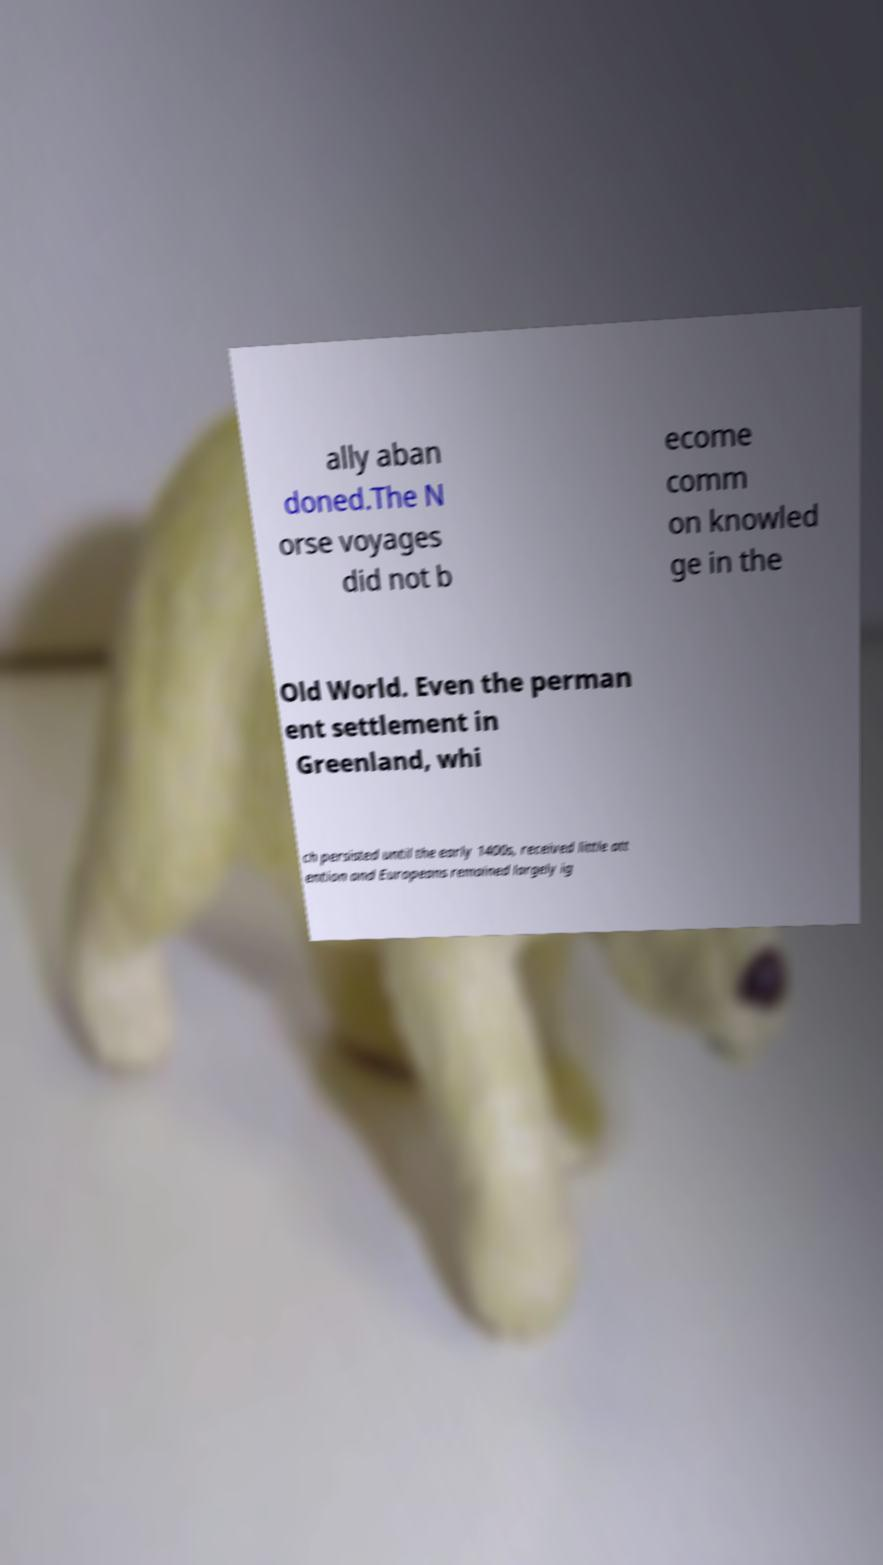Can you read and provide the text displayed in the image?This photo seems to have some interesting text. Can you extract and type it out for me? ally aban doned.The N orse voyages did not b ecome comm on knowled ge in the Old World. Even the perman ent settlement in Greenland, whi ch persisted until the early 1400s, received little att ention and Europeans remained largely ig 